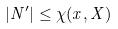Convert formula to latex. <formula><loc_0><loc_0><loc_500><loc_500>| N ^ { \prime } | \leq \chi ( x , X )</formula> 